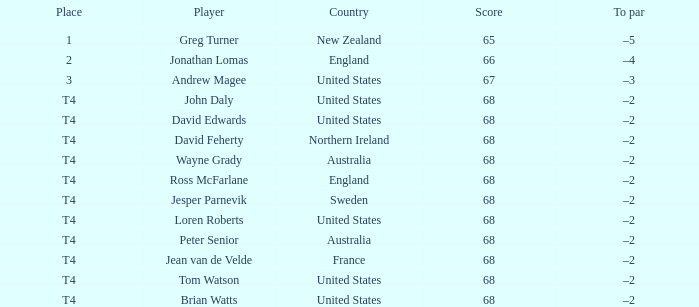Name the Score united states of tom watson in united state? 68.0. 